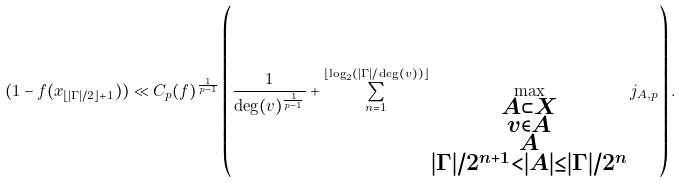<formula> <loc_0><loc_0><loc_500><loc_500>( 1 - f ( x _ { \lfloor | \Gamma | / 2 \rfloor + 1 } ) ) \ll C _ { p } ( f ) ^ { \frac { 1 } { p - 1 } } \left ( \frac { 1 } { \deg ( v ) ^ { \frac { 1 } { p - 1 } } } + \sum _ { n = 1 } ^ { \lfloor \log _ { 2 } ( | \Gamma | / \deg ( v ) ) \rfloor } \max _ { \substack { A \subset X \\ v \in A \\ A \\ | \Gamma | / 2 ^ { n + 1 } < | A | \leq | \Gamma | / 2 ^ { n } } } j _ { A , p } \right ) .</formula> 